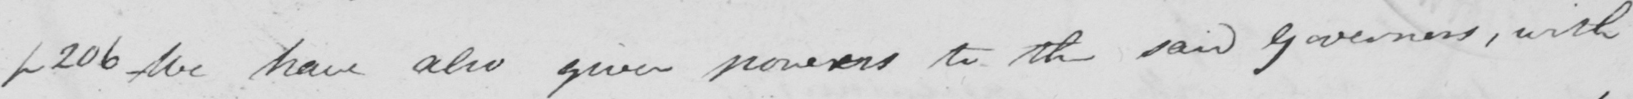What text is written in this handwritten line? p206 We have also given powers to the said governors , with 